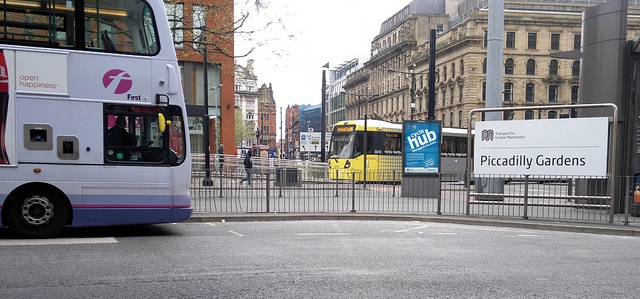Describe the objects in this image and their specific colors. I can see bus in gray, darkgray, and black tones, bus in gray, black, khaki, and tan tones, people in gray, black, and purple tones, and people in gray, black, and darkgray tones in this image. 